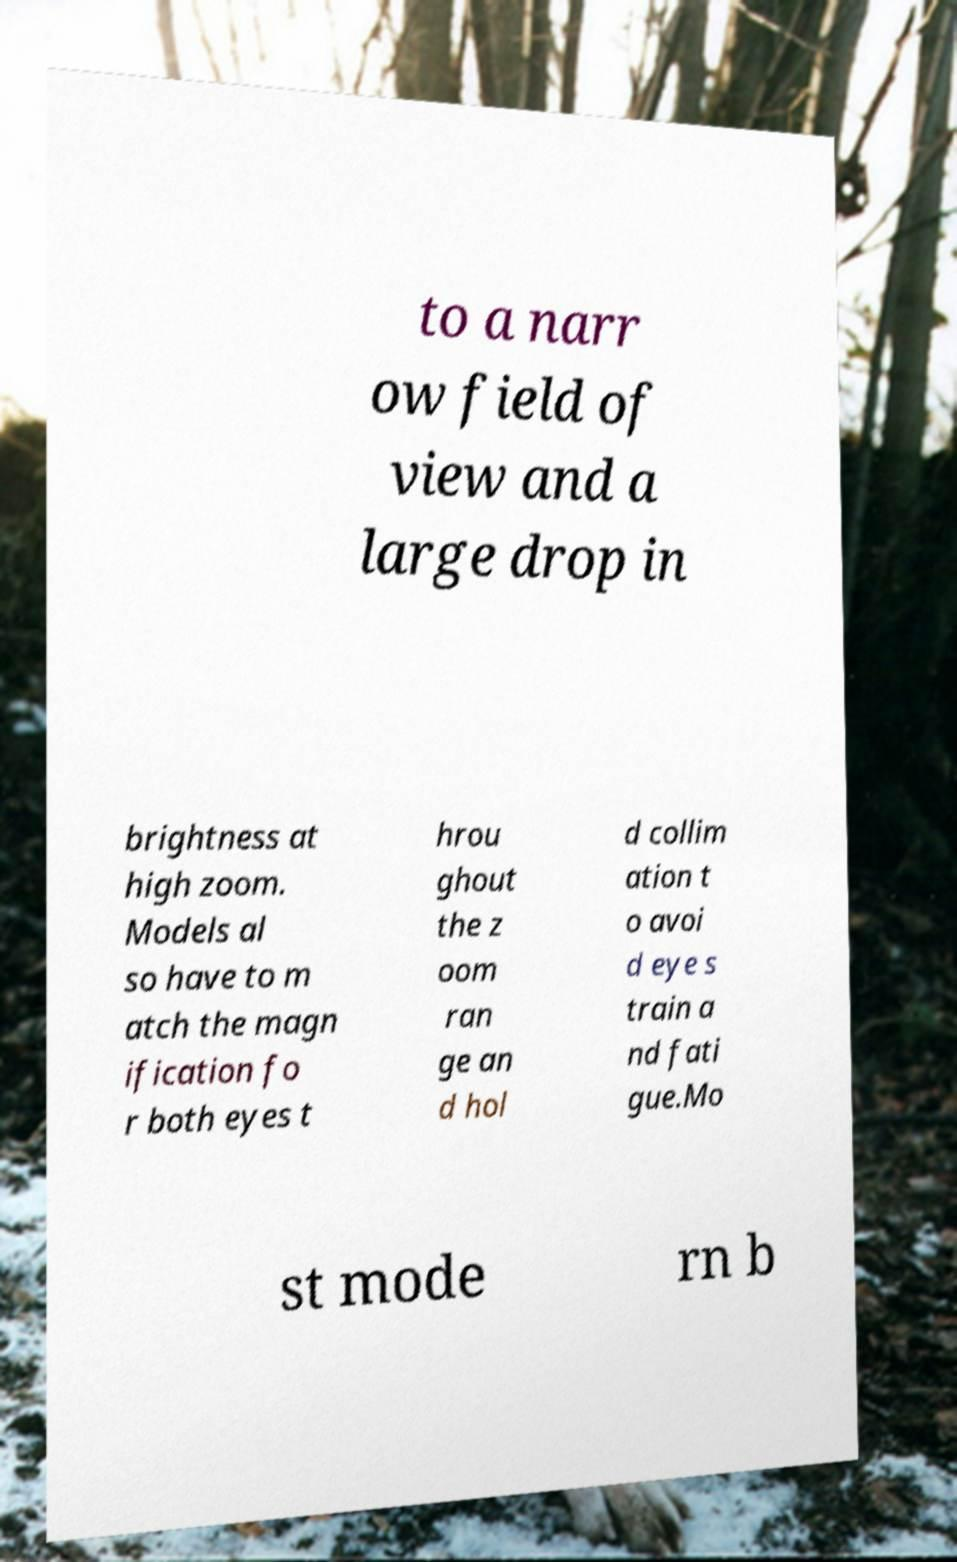Could you assist in decoding the text presented in this image and type it out clearly? to a narr ow field of view and a large drop in brightness at high zoom. Models al so have to m atch the magn ification fo r both eyes t hrou ghout the z oom ran ge an d hol d collim ation t o avoi d eye s train a nd fati gue.Mo st mode rn b 